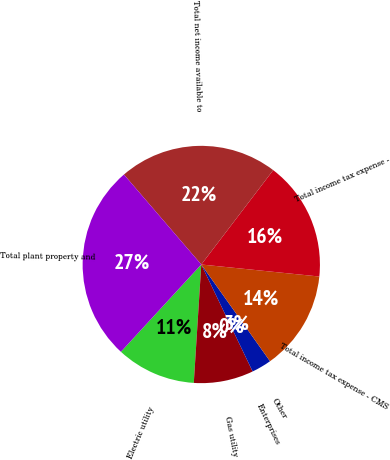Convert chart. <chart><loc_0><loc_0><loc_500><loc_500><pie_chart><fcel>Electric utility<fcel>Gas utility<fcel>Enterprises<fcel>Other<fcel>Total income tax expense - CMS<fcel>Total income tax expense -<fcel>Total net income available to<fcel>Total plant property and<nl><fcel>10.84%<fcel>8.13%<fcel>0.0%<fcel>2.71%<fcel>13.55%<fcel>16.25%<fcel>21.67%<fcel>26.85%<nl></chart> 